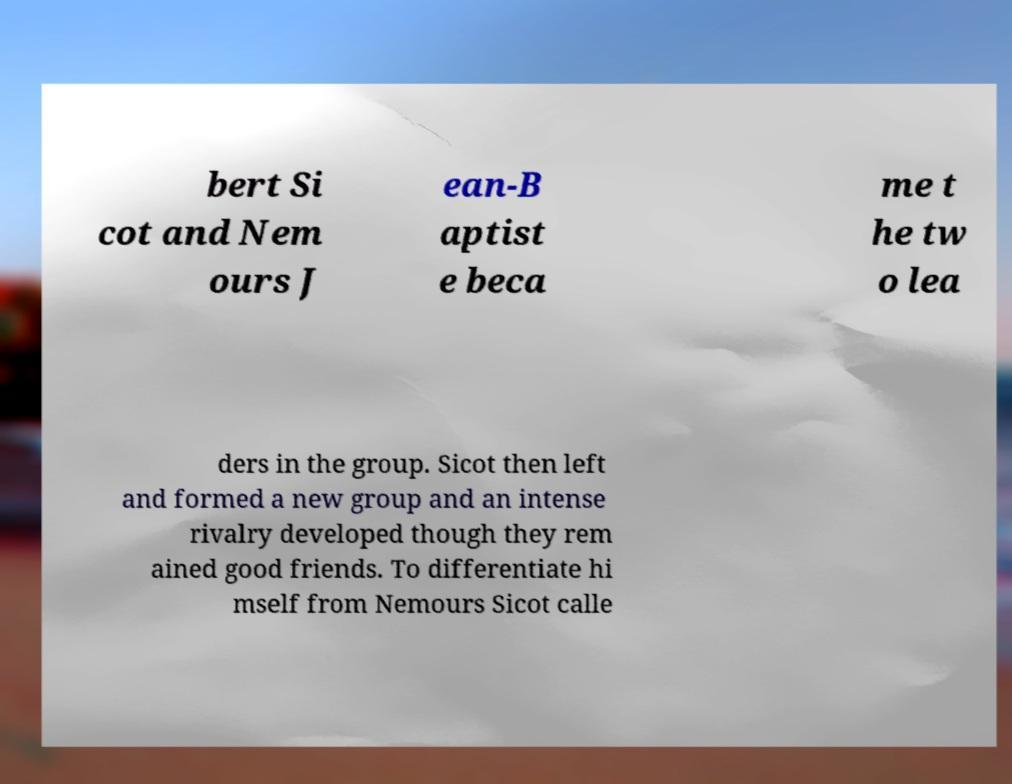For documentation purposes, I need the text within this image transcribed. Could you provide that? bert Si cot and Nem ours J ean-B aptist e beca me t he tw o lea ders in the group. Sicot then left and formed a new group and an intense rivalry developed though they rem ained good friends. To differentiate hi mself from Nemours Sicot calle 